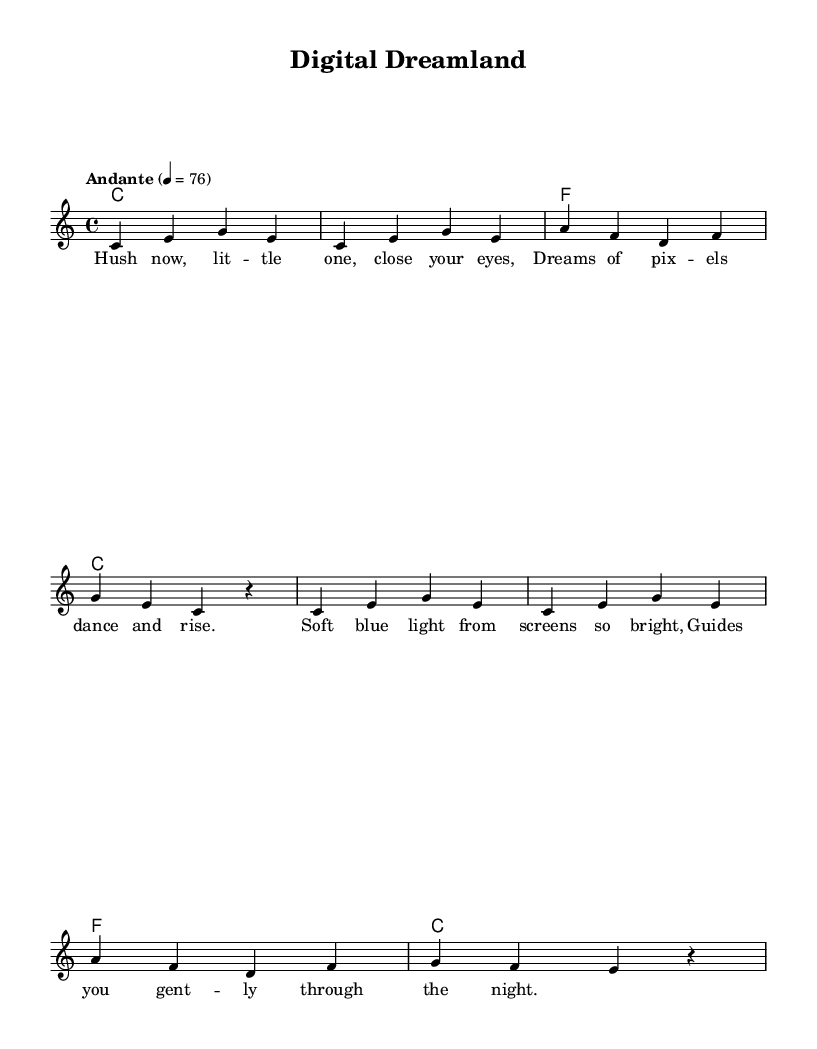what is the key signature of this music? The key signature is indicated at the beginning of the staff. In this piece, it shows no sharps or flats, which means it is in C major.
Answer: C major what is the time signature of this music? The time signature is found at the beginning of the staff as well. It indicates that there are 4 beats in each measure, represented as 4/4.
Answer: 4/4 what is the tempo marking of the music? The tempo is specified in words above the staff. It indicates the speed at which the piece should be played, which is "Andante" with a metronome marking of 76.
Answer: Andante 76 how many measures are in the melody section? By counting the groupings of notes separated by vertical lines, we can see that there are a total of 8 measures in the melody section.
Answer: 8 what is the mood conveyed by the lyrics of this lullaby? The lyrics provide a gentle and soothing mood, focusing on themes of comfort and light, ideal for a lullaby intended for children.
Answer: Soothing what is the primary instrument indicated in this sheet music? The instrument is not explicitly stated but is typically assumed to be a piano, as denoted by the inclusion of melody and harmonies.
Answer: Piano what is a unique characteristic of this lullaby compared to traditional ones? This lullaby incorporates modern themes like "screens" and "pixels," distinguishing it from more traditional lullabies which often focus solely on nature or classic imagery.
Answer: Contemporary themes 